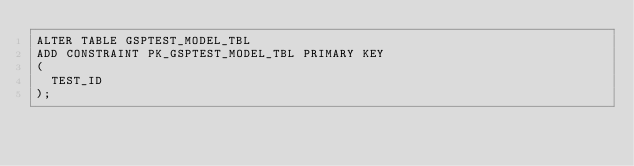Convert code to text. <code><loc_0><loc_0><loc_500><loc_500><_SQL_>ALTER TABLE GSPTEST_MODEL_TBL
ADD CONSTRAINT PK_GSPTEST_MODEL_TBL PRIMARY KEY
(
  TEST_ID
);
</code> 